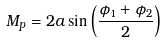<formula> <loc_0><loc_0><loc_500><loc_500>M _ { p } = 2 a \sin \left ( \frac { \phi _ { 1 } + \phi _ { 2 } } { 2 } \right )</formula> 